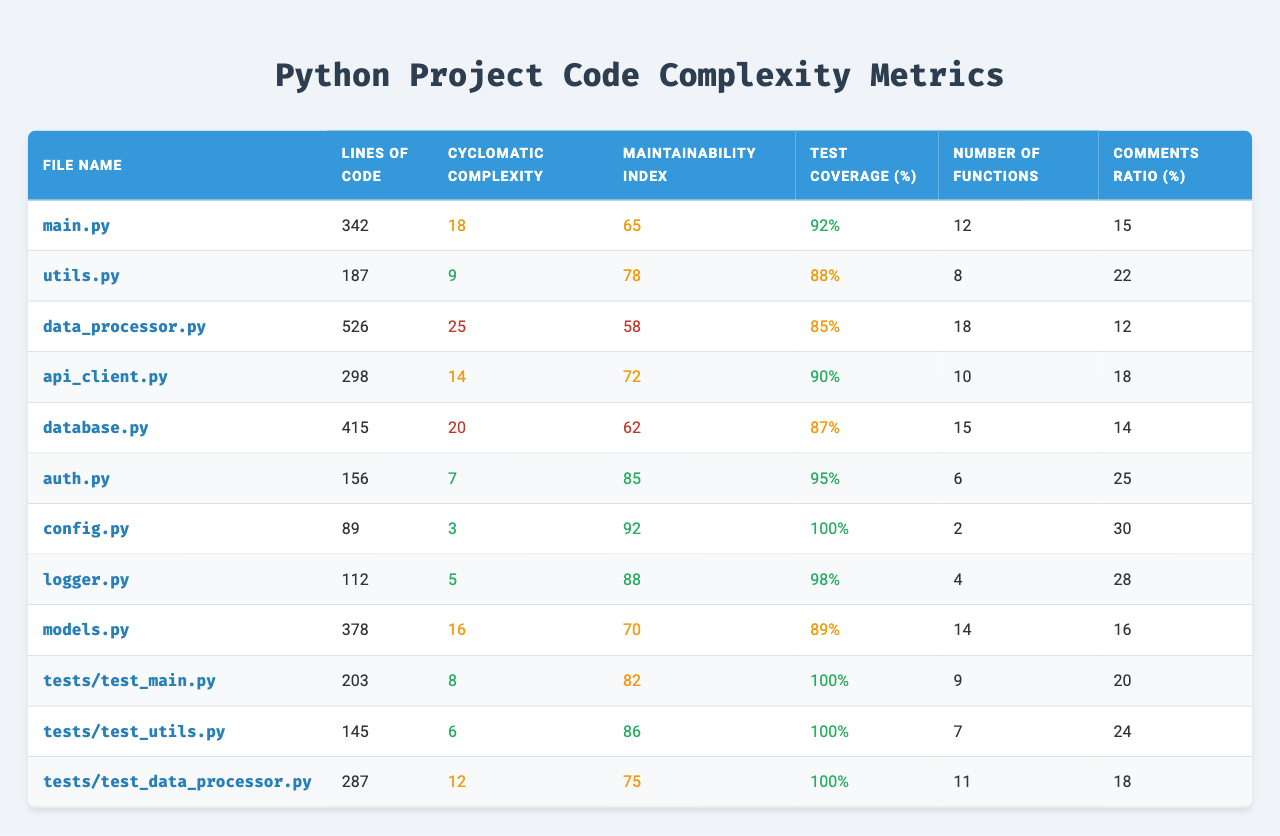What is the cyclomatic complexity of the `data_processor.py` file? The cyclomatic complexity value for `data_processor.py` is found in the corresponding row under the "Cyclomatic Complexity" column, which shows a value of 25.
Answer: 25 Which file has the highest maintainability index? By comparing the "Maintainability Index" values across all files in the table, we see that `config.py` has the highest value of 92.
Answer: config.py Is the test coverage for `tests/test_main.py` 100%? The test coverage percentage for `tests/test_main.py` is listed as 100% in the table, confirming it meets the criteria.
Answer: Yes What is the average lines of code across all files? First, sum the lines of code: (342 + 187 + 526 + 298 + 415 + 156 + 89 + 112 + 378 + 203 + 145 + 287) = 2837. Then divide by the number of files (12): 2837 / 12 = 236.42
Answer: 236.42 Which file has the lowest comments ratio, and what is that value? Checking the "Comments Ratio (%)" column, the lowest value is 12%, associated with the `data_processor.py` file.
Answer: data_processor.py, 12% Are there more functions in `auth.py` or in `logger.py`? The number of functions in `auth.py` is 6 and in `logger.py` is 4. Since 6 is greater than 4, `auth.py` has more functions.
Answer: auth.py What is the difference in cyclomatic complexity between `main.py` and `utils.py`? The cyclomatic complexity for `main.py` is 18, and for `utils.py` it is 9. The difference is calculated as 18 - 9 = 9.
Answer: 9 Does any file have both test coverage and maintainability index over 90? Checking the table, `config.py` has a test coverage of 100% and a maintainability index of 92, which meets the criteria.
Answer: Yes Which file has the highest cyclomatic complexity, and what is its value? Reviewing the cyclomatic complexity values, `data_processor.py` has the highest complexity score of 25.
Answer: data_processor.py, 25 What is the total number of functions in all the test files combined? Adding the number of functions from the test files: (9 + 7 + 11) = 27.
Answer: 27 